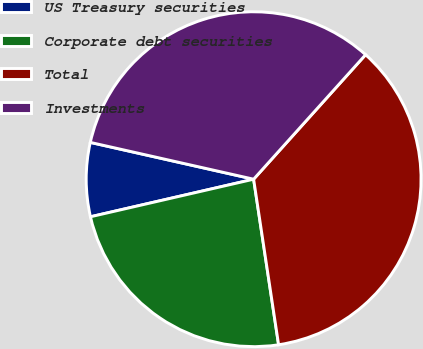Convert chart. <chart><loc_0><loc_0><loc_500><loc_500><pie_chart><fcel>US Treasury securities<fcel>Corporate debt securities<fcel>Total<fcel>Investments<nl><fcel>7.13%<fcel>23.78%<fcel>35.96%<fcel>33.13%<nl></chart> 